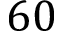<formula> <loc_0><loc_0><loc_500><loc_500>6 0</formula> 